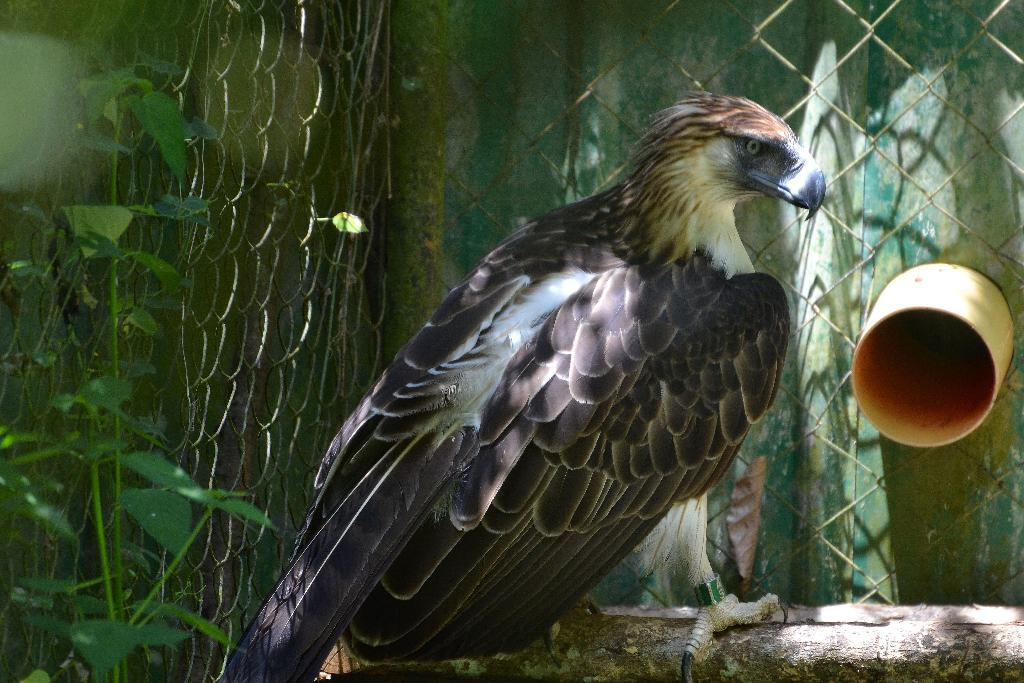What type of animal can be seen in the image? There is a bird in the image. What can be found on the left side of the image? There are plants on the left side of the image. What is the school's rate of success in the image? There is no school or any indication of success rates in the image; it features a bird and plants. 